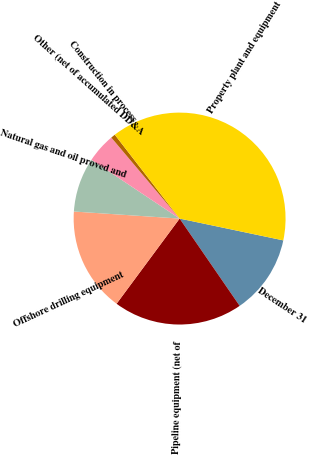Convert chart to OTSL. <chart><loc_0><loc_0><loc_500><loc_500><pie_chart><fcel>December 31<fcel>Pipeline equipment (net of<fcel>Offshore drilling equipment<fcel>Natural gas and oil proved and<fcel>Other (net of accumulated DD&A<fcel>Construction in process<fcel>Property plant and equipment<nl><fcel>12.11%<fcel>19.73%<fcel>15.92%<fcel>8.3%<fcel>4.49%<fcel>0.68%<fcel>38.77%<nl></chart> 